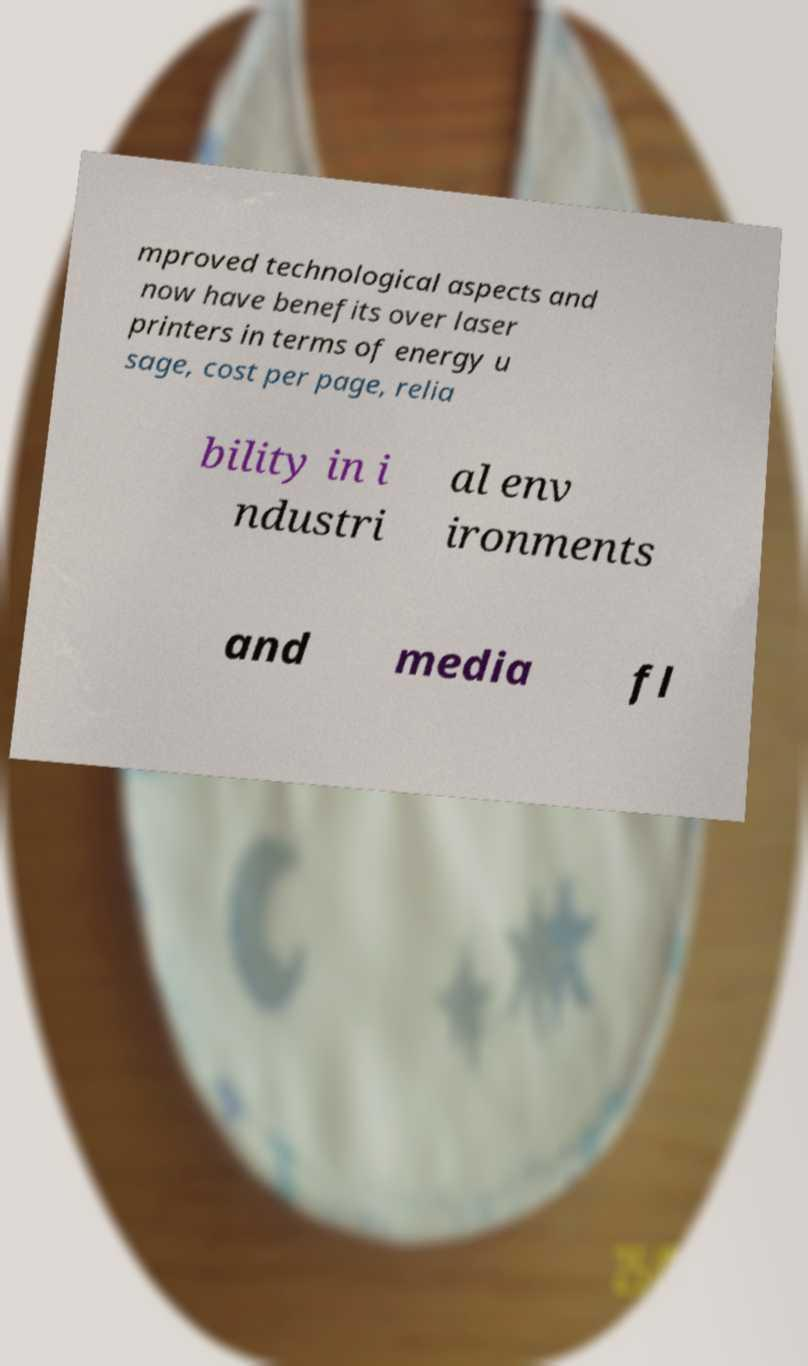Could you extract and type out the text from this image? mproved technological aspects and now have benefits over laser printers in terms of energy u sage, cost per page, relia bility in i ndustri al env ironments and media fl 